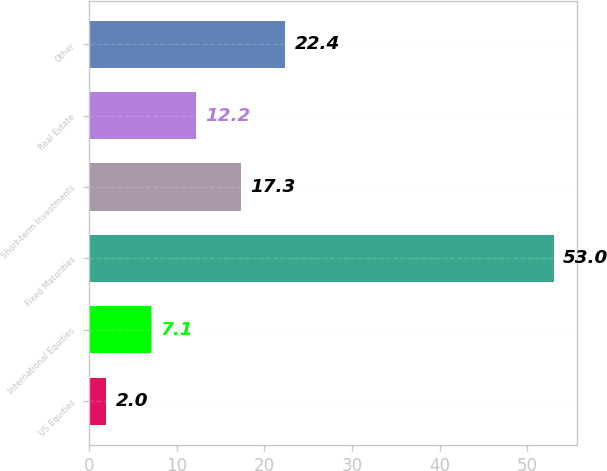<chart> <loc_0><loc_0><loc_500><loc_500><bar_chart><fcel>US Equities<fcel>International Equities<fcel>Fixed Maturities<fcel>Short-term Investments<fcel>Real Estate<fcel>Other<nl><fcel>2<fcel>7.1<fcel>53<fcel>17.3<fcel>12.2<fcel>22.4<nl></chart> 